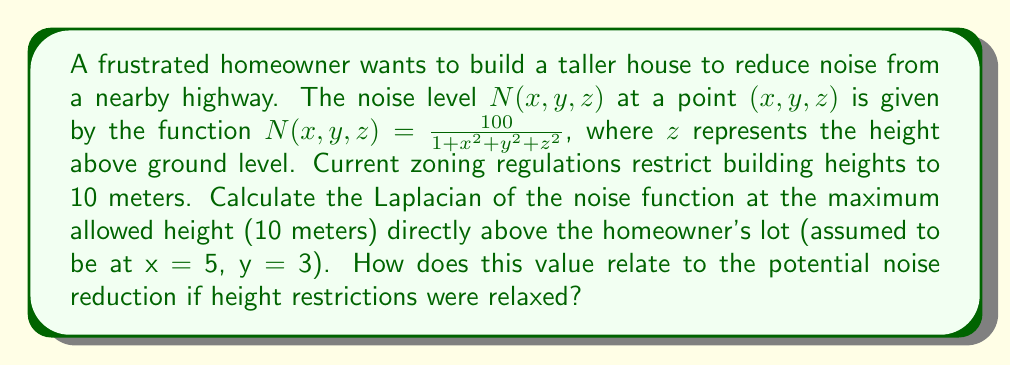What is the answer to this math problem? To solve this problem, we'll follow these steps:

1) The Laplacian in 3D Cartesian coordinates is given by:

   $$\nabla^2 N = \frac{\partial^2 N}{\partial x^2} + \frac{\partial^2 N}{\partial y^2} + \frac{\partial^2 N}{\partial z^2}$$

2) Let's calculate each second partial derivative:

   $$\frac{\partial N}{\partial x} = -\frac{200x}{(1 + x^2 + y^2 + z^2)^2}$$
   
   $$\frac{\partial^2 N}{\partial x^2} = -\frac{200(1 + x^2 + y^2 + z^2)^2 - 800x^2(1 + x^2 + y^2 + z^2)}{(1 + x^2 + y^2 + z^2)^4}$$

   Similarly for y and z:

   $$\frac{\partial^2 N}{\partial y^2} = -\frac{200(1 + x^2 + y^2 + z^2)^2 - 800y^2(1 + x^2 + y^2 + z^2)}{(1 + x^2 + y^2 + z^2)^4}$$

   $$\frac{\partial^2 N}{\partial z^2} = -\frac{200(1 + x^2 + y^2 + z^2)^2 - 800z^2(1 + x^2 + y^2 + z^2)}{(1 + x^2 + y^2 + z^2)^4}$$

3) The Laplacian is the sum of these three terms:

   $$\nabla^2 N = -\frac{600(1 + x^2 + y^2 + z^2)^2 - 800(x^2 + y^2 + z^2)(1 + x^2 + y^2 + z^2)}{(1 + x^2 + y^2 + z^2)^4}$$

4) Simplify:

   $$\nabla^2 N = \frac{200(3 - x^2 - y^2 - z^2)}{(1 + x^2 + y^2 + z^2)^3}$$

5) Now, we evaluate this at x = 5, y = 3, z = 10:

   $$\nabla^2 N|_{(5,3,10)} = \frac{200(3 - 5^2 - 3^2 - 10^2)}{(1 + 5^2 + 3^2 + 10^2)^3}$$

6) Simplify:

   $$\nabla^2 N|_{(5,3,10)} = \frac{200(-131)}{135^3} \approx -0.0102$$

The negative Laplacian indicates that the noise level is decreasing more rapidly than the average of its surroundings at this point. If height restrictions were relaxed, allowing for taller buildings, the homeowner could potentially experience even greater noise reduction at higher elevations.
Answer: $-0.0102$ 